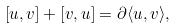Convert formula to latex. <formula><loc_0><loc_0><loc_500><loc_500>[ u , v ] + [ v , u ] = \partial \langle u , v \rangle ,</formula> 